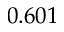<formula> <loc_0><loc_0><loc_500><loc_500>0 . 6 0 1</formula> 